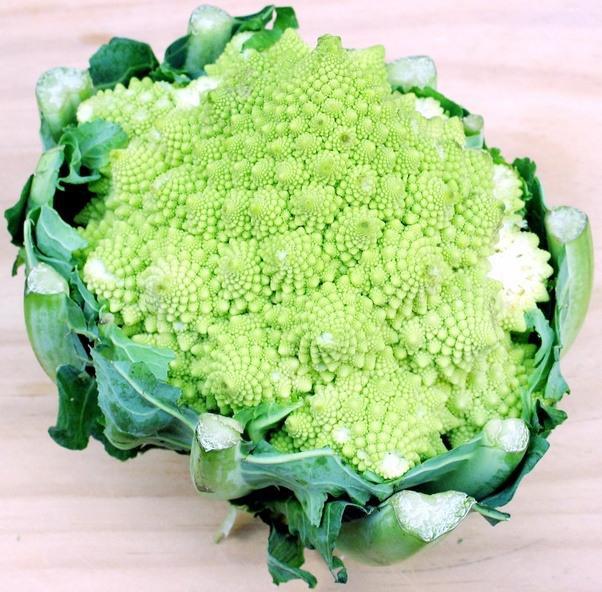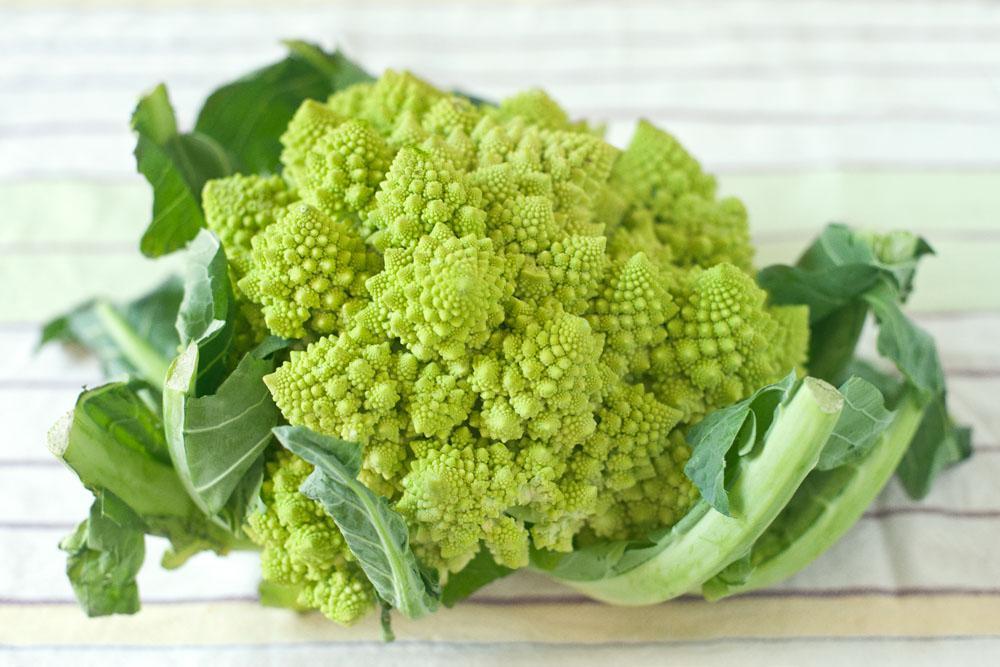The first image is the image on the left, the second image is the image on the right. Assess this claim about the two images: "The left and right image contains the same number of romanesco broccoli.". Correct or not? Answer yes or no. Yes. 